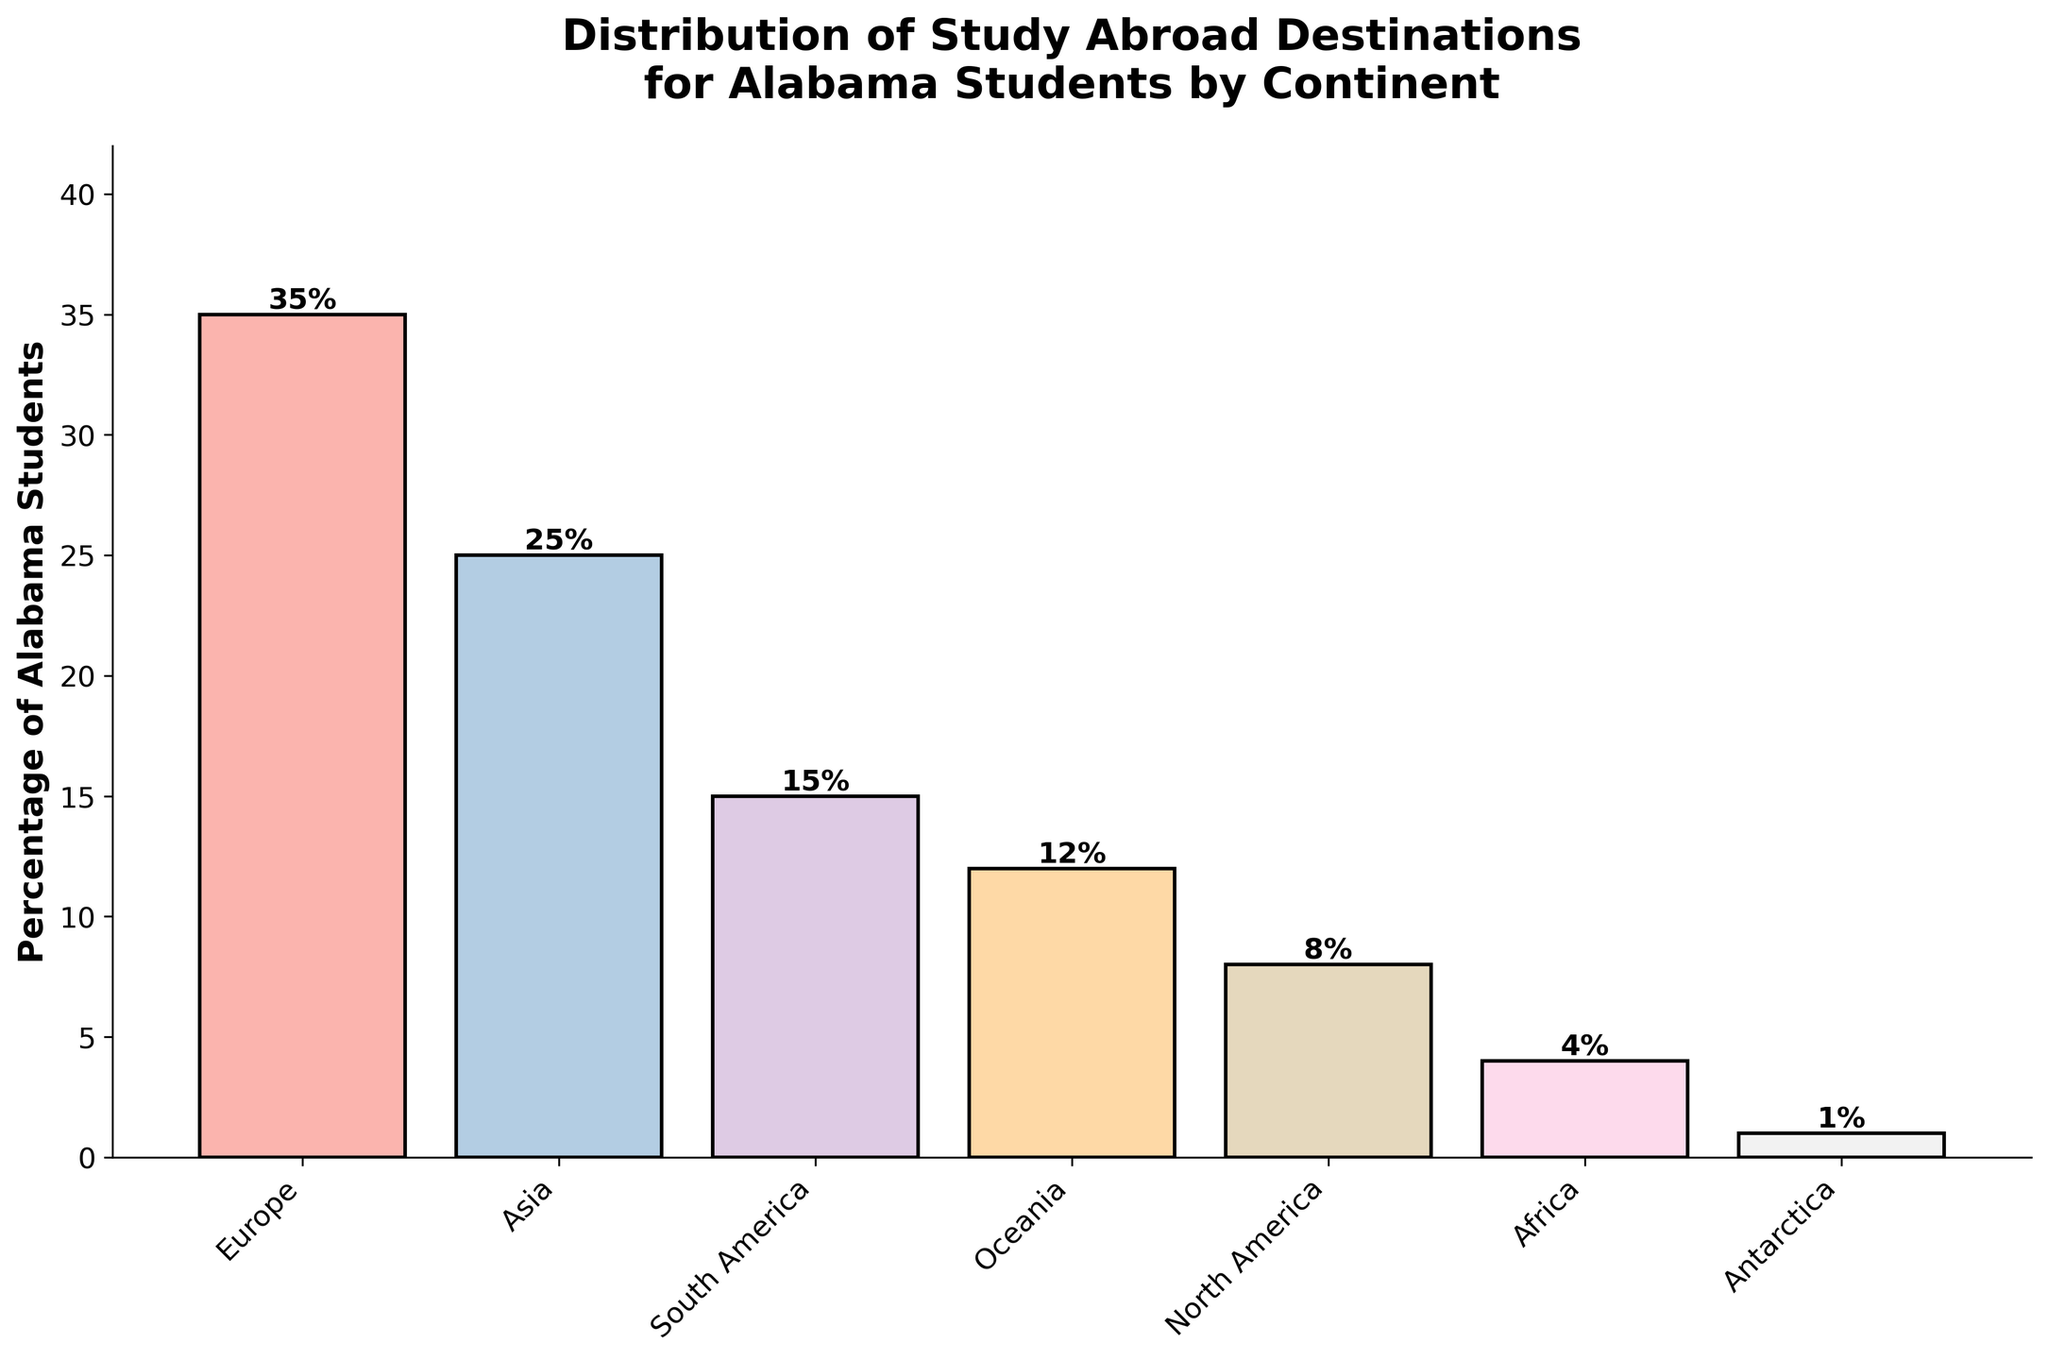What continent has the highest percentage of Alabama students studying abroad? By examining the figure, we can see that the bar representing Europe is the tallest one, indicating it has the highest percentage of Alabama students studying abroad.
Answer: Europe What is the total percentage of Alabama students studying abroad in Oceania and Asia? First, we identify the individual percentages for Oceania (12%) and Asia (25%). Summing them up, we get 12% + 25% = 37%.
Answer: 37% Which continent has a lower percentage of Alabama students studying abroad: North America or South America? By comparing the heights of the bars, we see that the bar for North America is shorter than the one for South America, indicating that North America has a lower percentage. Specifically, North America has 8%, and South America has 15%.
Answer: North America What is the difference in percentage between the continent with the highest and the lowest percentage of Alabama students studying abroad? The continent with the highest percentage is Europe at 35%, and the lowest is Antarctica at 1%. The difference is 35% - 1% = 34%.
Answer: 34% How many continents have a percentage of Alabama students studying abroad that is above 10%? From the figure, we see that Europe (35%), Asia (25%), South America (15%), and Oceania (12%) have percentages above 10%. Hence, there are four continents.
Answer: 4 Is the percentage of Alabama students studying abroad in Asia greater than the percentage in South America and North America combined? The percentage for Asia is 25%. The combined percentage for South America (15%) and North America (8%) is 15% + 8% = 23%. Since 25% is greater than 23%, the answer is yes.
Answer: Yes What is the average percentage of Alabama students studying abroad in Europe, Asia, and South America? The percentages for Europe, Asia, and South America are 35%, 25%, and 15%, respectively. Adding them gives 35% + 25% + 15% = 75%. The average is then 75% / 3 = 25%.
Answer: 25% Which continents have percentages of Alabama students studying abroad that are equal to or less than 10%? From the figure, we see that the continents with percentages equal to or less than 10% are North America (8%), Africa (4%), and Antarctica (1%).
Answer: North America, Africa, Antarctica How much taller is the bar for Europe compared to the bar for Oceania? The percentage for Europe is 35%, while for Oceania, it is 12%. Therefore, the difference in their heights (percentages) is 35% - 12% = 23%.
Answer: 23% What is the median percentage of Alabama students studying abroad by continent? The sorted percentages are 1%, 4%, 8%, 12%, 15%, 25%, 35%. Since there are 7 data points, the median is the fourth value in the sorted list, which is 12%.
Answer: 12% 